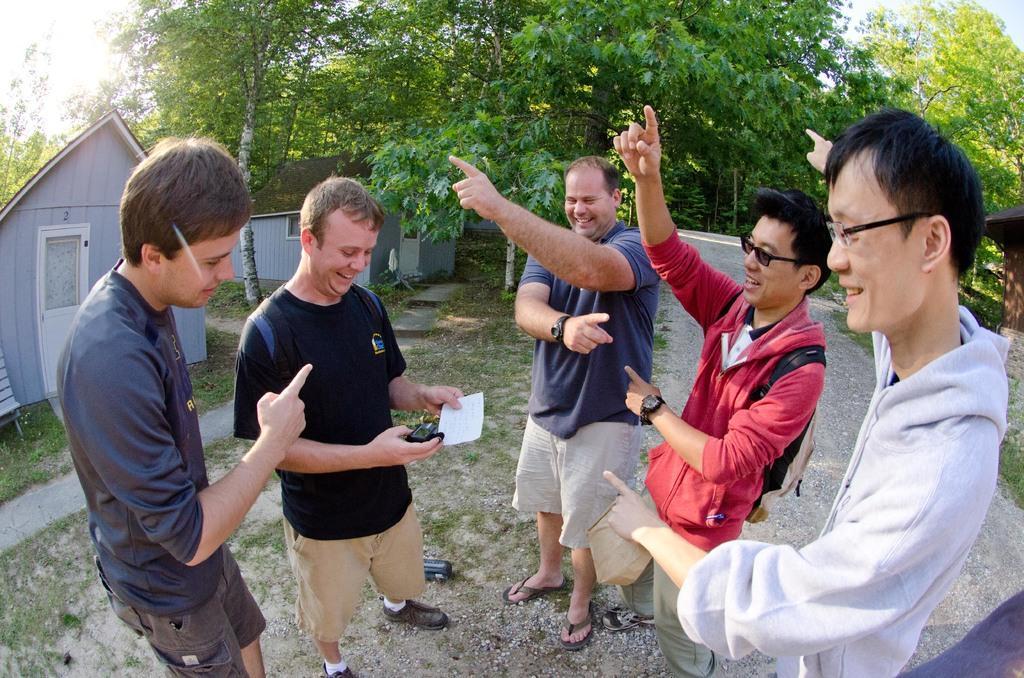In one or two sentences, can you explain what this image depicts? In the picture there are men standing and smiling, among them this man holding a paper and object and we can see houses, grass and trees. In the background of the image we can see sky. 